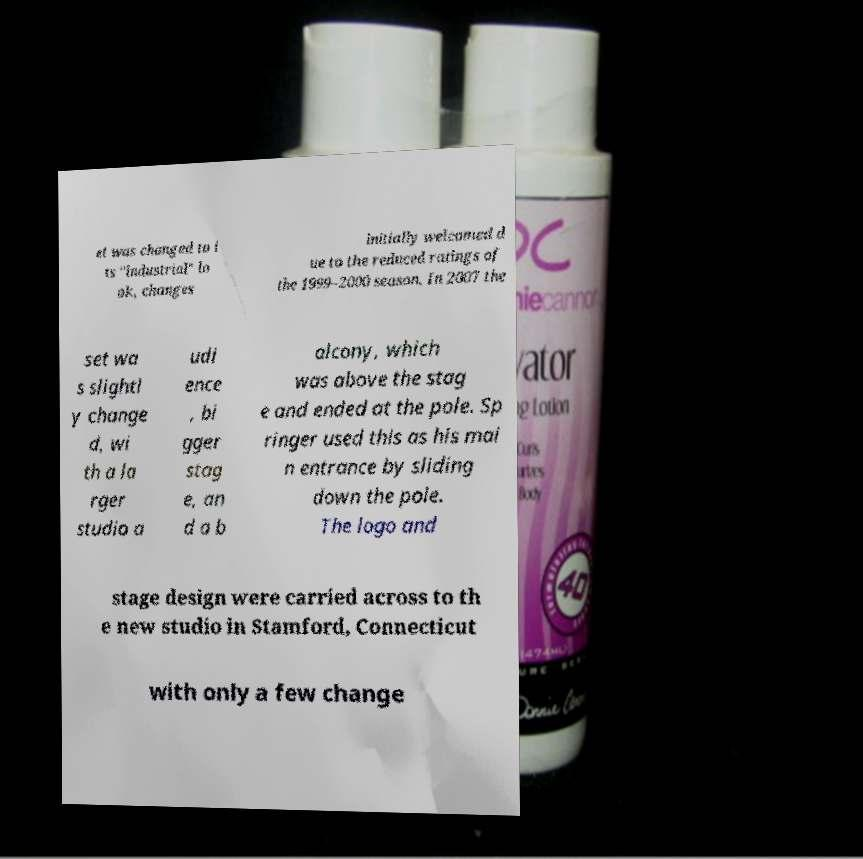Can you read and provide the text displayed in the image?This photo seems to have some interesting text. Can you extract and type it out for me? et was changed to i ts "industrial" lo ok, changes initially welcomed d ue to the reduced ratings of the 1999–2000 season. In 2007 the set wa s slightl y change d, wi th a la rger studio a udi ence , bi gger stag e, an d a b alcony, which was above the stag e and ended at the pole. Sp ringer used this as his mai n entrance by sliding down the pole. The logo and stage design were carried across to th e new studio in Stamford, Connecticut with only a few change 